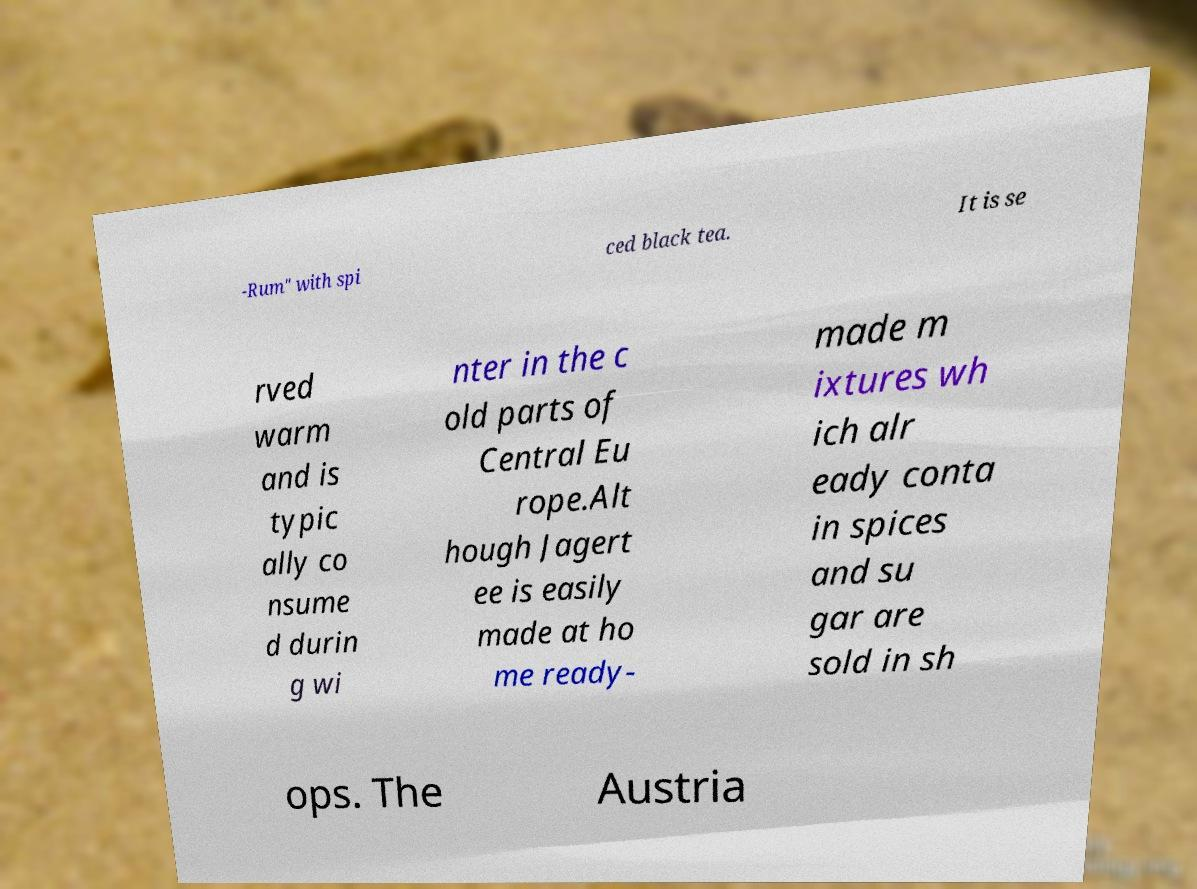Could you extract and type out the text from this image? -Rum" with spi ced black tea. It is se rved warm and is typic ally co nsume d durin g wi nter in the c old parts of Central Eu rope.Alt hough Jagert ee is easily made at ho me ready- made m ixtures wh ich alr eady conta in spices and su gar are sold in sh ops. The Austria 